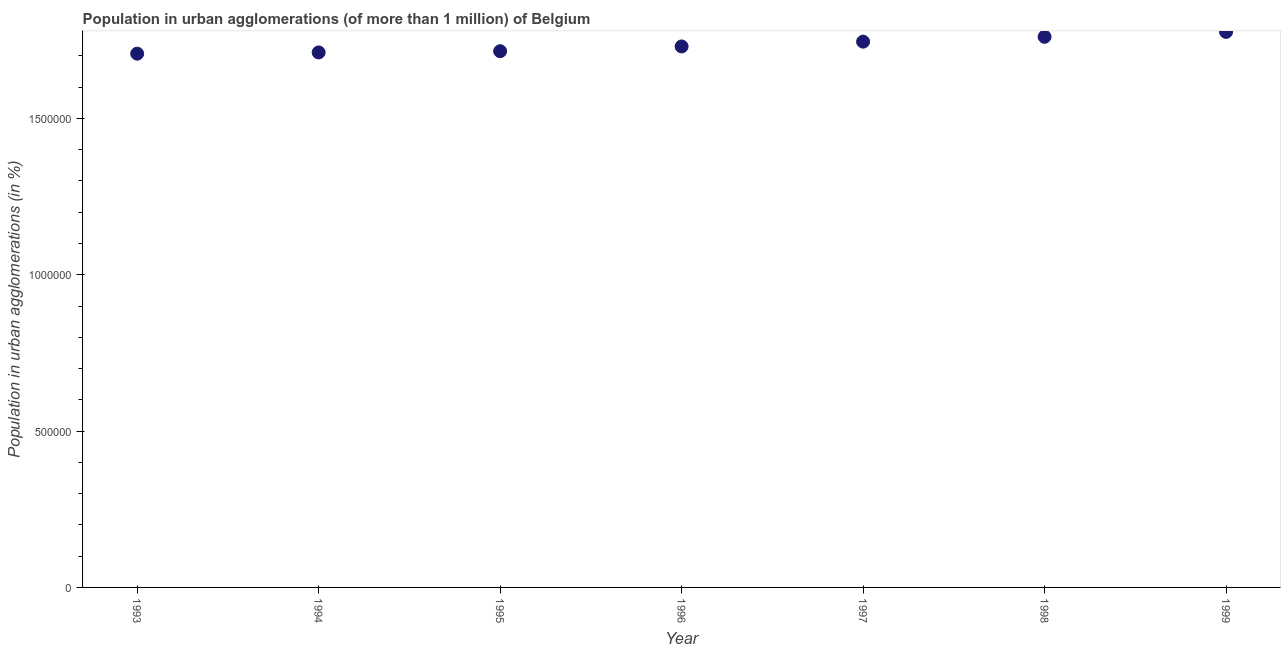What is the population in urban agglomerations in 1995?
Give a very brief answer. 1.71e+06. Across all years, what is the maximum population in urban agglomerations?
Provide a short and direct response. 1.78e+06. Across all years, what is the minimum population in urban agglomerations?
Provide a short and direct response. 1.71e+06. In which year was the population in urban agglomerations minimum?
Offer a very short reply. 1993. What is the sum of the population in urban agglomerations?
Your answer should be very brief. 1.21e+07. What is the difference between the population in urban agglomerations in 1993 and 1999?
Offer a terse response. -6.95e+04. What is the average population in urban agglomerations per year?
Provide a short and direct response. 1.74e+06. What is the median population in urban agglomerations?
Give a very brief answer. 1.73e+06. Do a majority of the years between 1996 and 1994 (inclusive) have population in urban agglomerations greater than 900000 %?
Your response must be concise. No. What is the ratio of the population in urban agglomerations in 1994 to that in 1997?
Provide a short and direct response. 0.98. Is the population in urban agglomerations in 1995 less than that in 1998?
Provide a short and direct response. Yes. Is the difference between the population in urban agglomerations in 1994 and 1996 greater than the difference between any two years?
Your response must be concise. No. What is the difference between the highest and the second highest population in urban agglomerations?
Offer a very short reply. 1.56e+04. Is the sum of the population in urban agglomerations in 1994 and 1996 greater than the maximum population in urban agglomerations across all years?
Offer a terse response. Yes. What is the difference between the highest and the lowest population in urban agglomerations?
Offer a very short reply. 6.95e+04. In how many years, is the population in urban agglomerations greater than the average population in urban agglomerations taken over all years?
Provide a short and direct response. 3. How many dotlines are there?
Offer a terse response. 1. Are the values on the major ticks of Y-axis written in scientific E-notation?
Provide a succinct answer. No. Does the graph contain any zero values?
Offer a terse response. No. What is the title of the graph?
Your answer should be very brief. Population in urban agglomerations (of more than 1 million) of Belgium. What is the label or title of the Y-axis?
Keep it short and to the point. Population in urban agglomerations (in %). What is the Population in urban agglomerations (in %) in 1993?
Provide a succinct answer. 1.71e+06. What is the Population in urban agglomerations (in %) in 1994?
Keep it short and to the point. 1.71e+06. What is the Population in urban agglomerations (in %) in 1995?
Keep it short and to the point. 1.71e+06. What is the Population in urban agglomerations (in %) in 1996?
Offer a terse response. 1.73e+06. What is the Population in urban agglomerations (in %) in 1997?
Make the answer very short. 1.75e+06. What is the Population in urban agglomerations (in %) in 1998?
Offer a terse response. 1.76e+06. What is the Population in urban agglomerations (in %) in 1999?
Your answer should be very brief. 1.78e+06. What is the difference between the Population in urban agglomerations (in %) in 1993 and 1994?
Your answer should be compact. -3910. What is the difference between the Population in urban agglomerations (in %) in 1993 and 1995?
Offer a very short reply. -7829. What is the difference between the Population in urban agglomerations (in %) in 1993 and 1996?
Your answer should be very brief. -2.31e+04. What is the difference between the Population in urban agglomerations (in %) in 1993 and 1997?
Provide a succinct answer. -3.84e+04. What is the difference between the Population in urban agglomerations (in %) in 1993 and 1998?
Your answer should be compact. -5.39e+04. What is the difference between the Population in urban agglomerations (in %) in 1993 and 1999?
Your response must be concise. -6.95e+04. What is the difference between the Population in urban agglomerations (in %) in 1994 and 1995?
Give a very brief answer. -3919. What is the difference between the Population in urban agglomerations (in %) in 1994 and 1996?
Give a very brief answer. -1.92e+04. What is the difference between the Population in urban agglomerations (in %) in 1994 and 1997?
Give a very brief answer. -3.45e+04. What is the difference between the Population in urban agglomerations (in %) in 1994 and 1998?
Provide a short and direct response. -5.00e+04. What is the difference between the Population in urban agglomerations (in %) in 1994 and 1999?
Provide a succinct answer. -6.56e+04. What is the difference between the Population in urban agglomerations (in %) in 1995 and 1996?
Ensure brevity in your answer.  -1.52e+04. What is the difference between the Population in urban agglomerations (in %) in 1995 and 1997?
Keep it short and to the point. -3.06e+04. What is the difference between the Population in urban agglomerations (in %) in 1995 and 1998?
Your answer should be compact. -4.61e+04. What is the difference between the Population in urban agglomerations (in %) in 1995 and 1999?
Keep it short and to the point. -6.17e+04. What is the difference between the Population in urban agglomerations (in %) in 1996 and 1997?
Give a very brief answer. -1.53e+04. What is the difference between the Population in urban agglomerations (in %) in 1996 and 1998?
Your answer should be very brief. -3.08e+04. What is the difference between the Population in urban agglomerations (in %) in 1996 and 1999?
Your answer should be compact. -4.65e+04. What is the difference between the Population in urban agglomerations (in %) in 1997 and 1998?
Make the answer very short. -1.55e+04. What is the difference between the Population in urban agglomerations (in %) in 1997 and 1999?
Provide a short and direct response. -3.11e+04. What is the difference between the Population in urban agglomerations (in %) in 1998 and 1999?
Offer a very short reply. -1.56e+04. What is the ratio of the Population in urban agglomerations (in %) in 1994 to that in 1997?
Your response must be concise. 0.98. What is the ratio of the Population in urban agglomerations (in %) in 1995 to that in 1996?
Your answer should be very brief. 0.99. What is the ratio of the Population in urban agglomerations (in %) in 1995 to that in 1997?
Provide a short and direct response. 0.98. What is the ratio of the Population in urban agglomerations (in %) in 1995 to that in 1999?
Provide a succinct answer. 0.96. What is the ratio of the Population in urban agglomerations (in %) in 1996 to that in 1997?
Offer a very short reply. 0.99. What is the ratio of the Population in urban agglomerations (in %) in 1996 to that in 1999?
Provide a short and direct response. 0.97. What is the ratio of the Population in urban agglomerations (in %) in 1998 to that in 1999?
Your response must be concise. 0.99. 